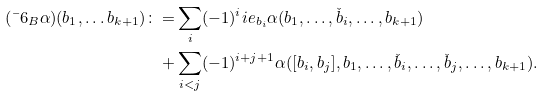Convert formula to latex. <formula><loc_0><loc_0><loc_500><loc_500>( \bar { \ } 6 _ { B } \alpha ) ( b _ { 1 } , \dots b _ { k + 1 } ) \colon = & \sum _ { i } ( - 1 ) ^ { i } \L i e _ { b _ { i } } \alpha ( b _ { 1 } , \dots , \check { b } _ { i } , \dots , b _ { k + 1 } ) \\ + & \sum _ { i < j } ( - 1 ) ^ { i + j + 1 } \alpha ( [ b _ { i } , b _ { j } ] , b _ { 1 } , \dots , \check { b } _ { i } , \dots , \check { b } _ { j } , \dots , b _ { k + 1 } ) .</formula> 